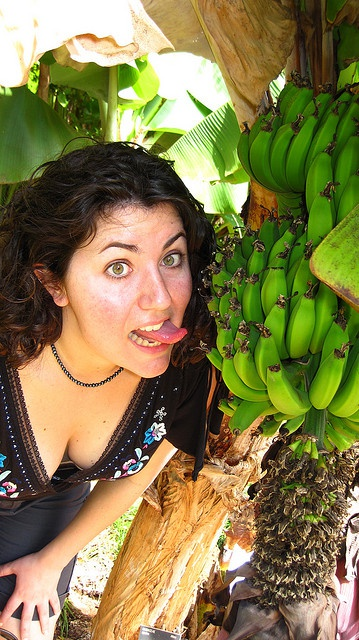Describe the objects in this image and their specific colors. I can see people in white, black, and tan tones and banana in white, darkgreen, green, and black tones in this image. 